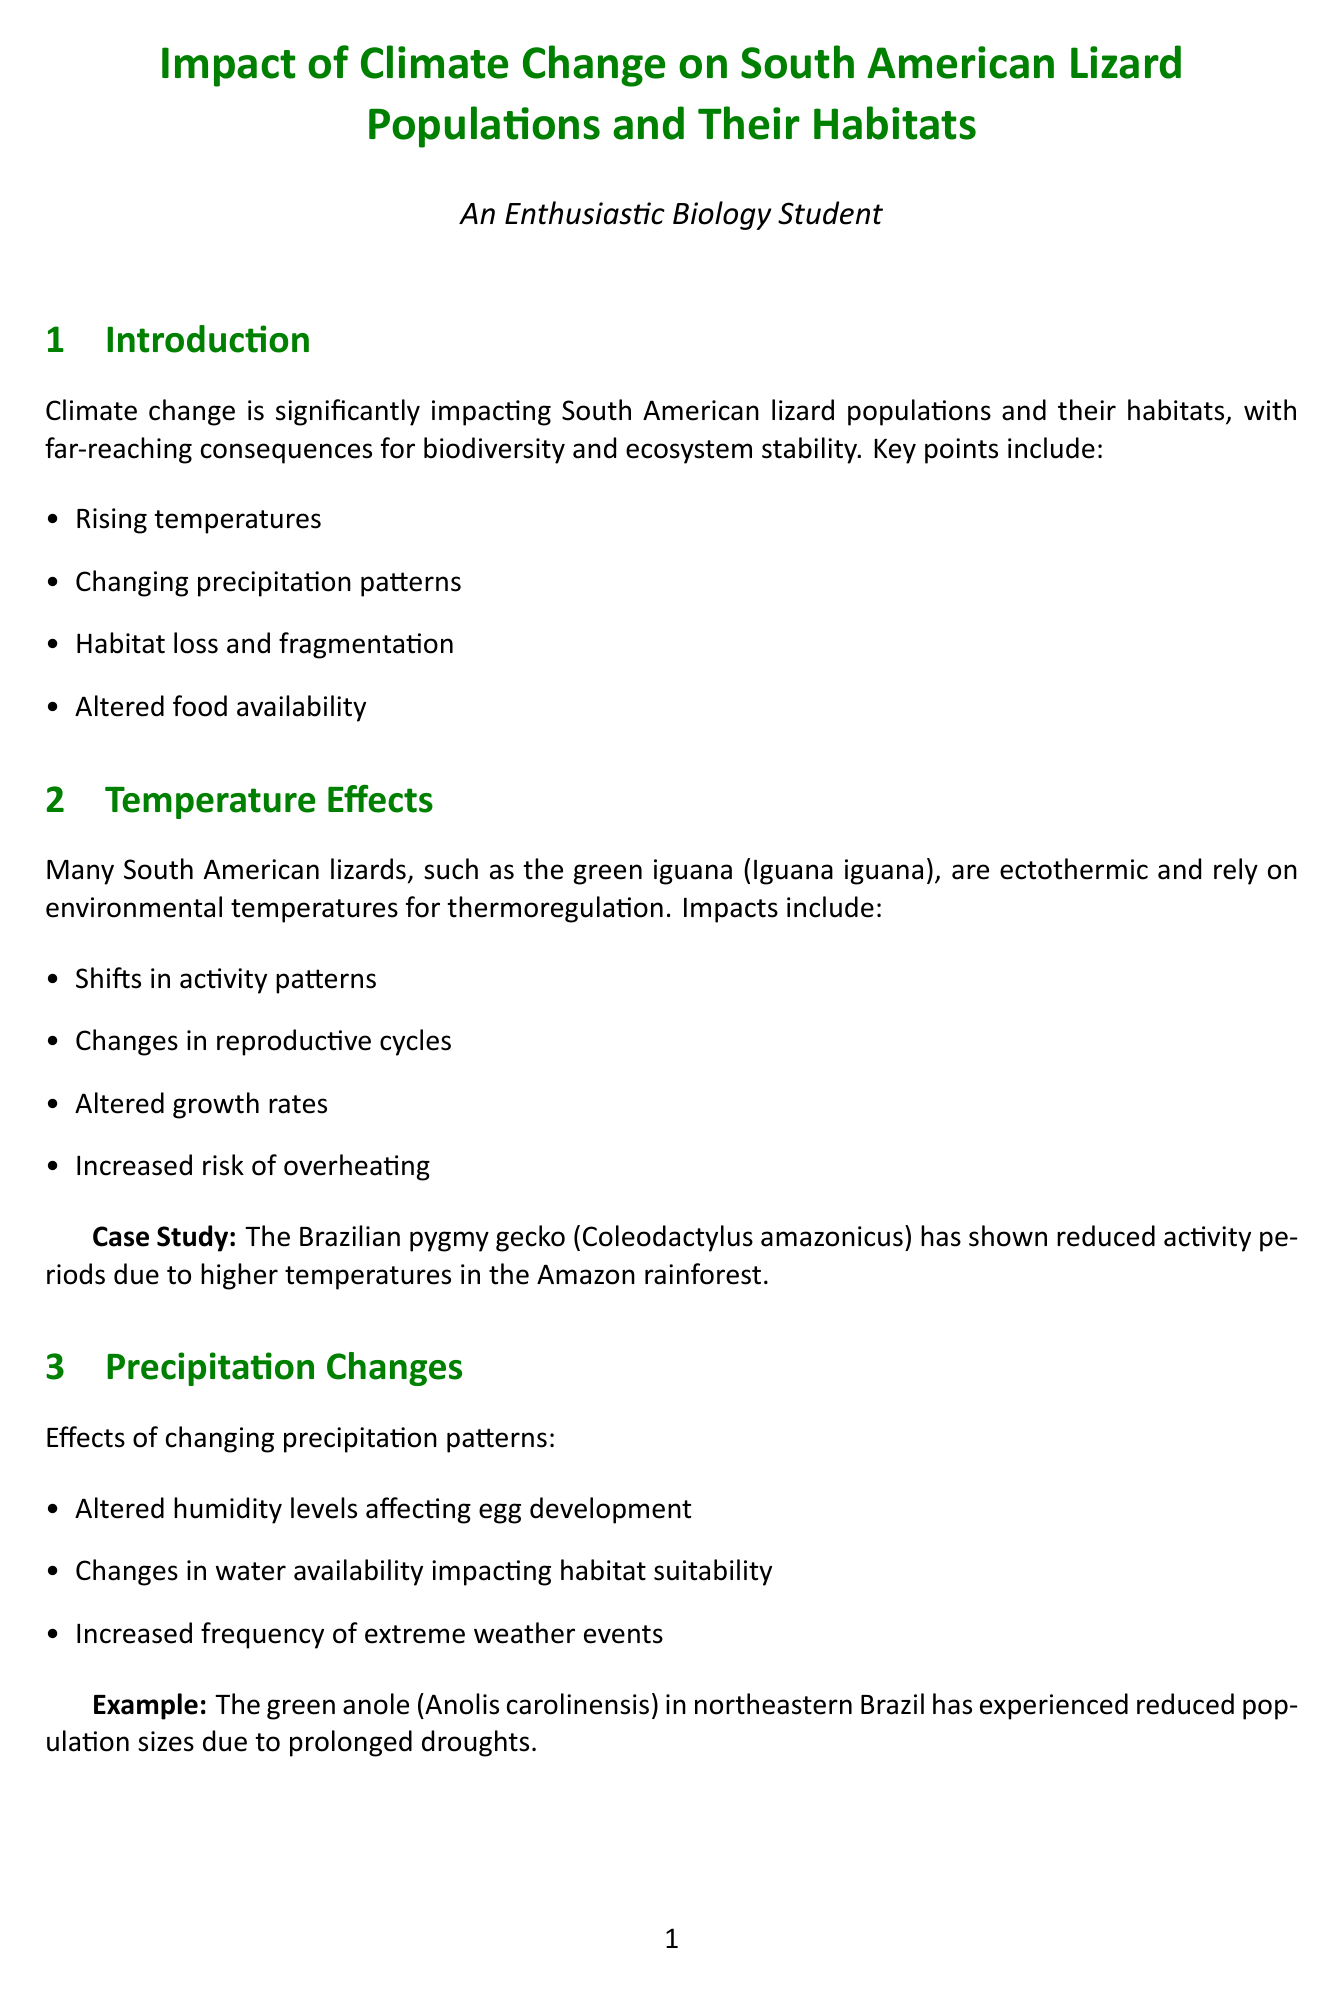What is the main focus of the report? The report focuses on the impact of climate change on South American lizard populations and their habitats.
Answer: Impact of climate change on South American lizard populations and their habitats Which species has shown reduced activity periods due to higher temperatures? The Brazilian pygmy gecko has shown reduced activity periods as a result of higher temperatures.
Answer: Brazilian pygmy gecko What major cause is leading to habitat loss for lizards? Deforestation is one of the major causes of habitat loss for lizards.
Answer: Deforestation What is one conservation strategy mentioned in the report? Establishment of protected areas and corridors is a conservation strategy highlighted in the report.
Answer: Establishment of protected areas and corridors Which lizard species has experienced changes in its diet due to climate-induced shifts? The San Lorenzo grass anole has experienced changes in its diet due to climate-induced shifts.
Answer: San Lorenzo grass anole What is a projected outcome for endemic species due to climate change? Potential extinctions of endemic species are projected as an outcome of climate change.
Answer: Potential extinctions of endemic species What are the observed adaptations of lizards to climate change? Behavioral changes in thermoregulation are one of the observed adaptations among lizards.
Answer: Behavioral changes in thermoregulation What university is conducting long-term monitoring of Andean lizard populations? The Pontifical Catholic University of Ecuador is conducting the long-term monitoring.
Answer: Pontifical Catholic University of Ecuador 